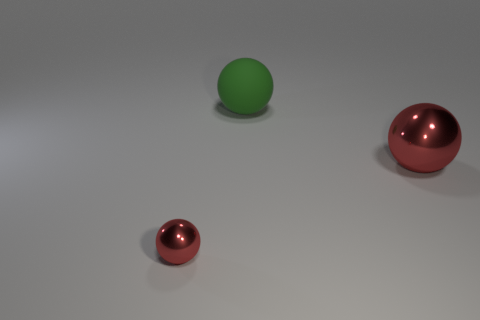There is a big ball that is the same color as the tiny object; what is its material?
Keep it short and to the point. Metal. What material is the big red object that is the same shape as the small metallic object?
Give a very brief answer. Metal. Does the tiny sphere have the same material as the green object?
Your answer should be very brief. No. How many other things are there of the same color as the tiny metal ball?
Provide a short and direct response. 1. The large rubber object is what color?
Ensure brevity in your answer.  Green. Is there any other thing that has the same material as the green ball?
Make the answer very short. No. Are there fewer big green things to the left of the tiny object than spheres that are left of the big green rubber sphere?
Offer a very short reply. Yes. What shape is the object that is in front of the large green matte ball and behind the small sphere?
Your answer should be very brief. Sphere. How many large red objects have the same shape as the tiny shiny object?
Your answer should be very brief. 1. The thing that is made of the same material as the tiny ball is what size?
Keep it short and to the point. Large. 